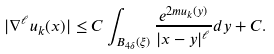<formula> <loc_0><loc_0><loc_500><loc_500>| \nabla ^ { \ell } u _ { k } ( x ) | \leq C \int _ { B _ { 4 \delta } ( \xi ) } \frac { e ^ { 2 m u _ { k } ( y ) } } { | x - y | ^ { \ell } } d y + C .</formula> 